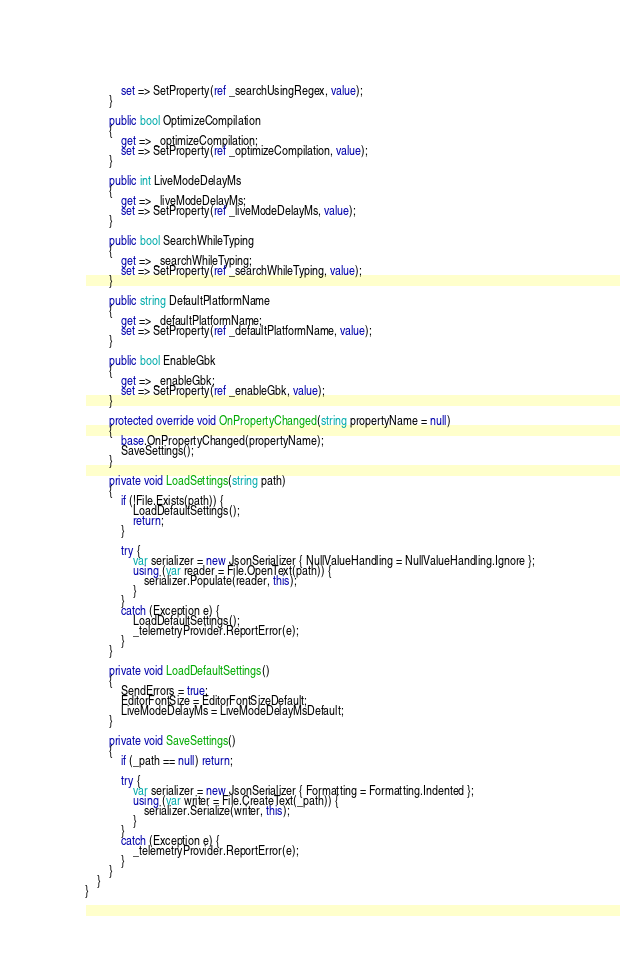Convert code to text. <code><loc_0><loc_0><loc_500><loc_500><_C#_>            set => SetProperty(ref _searchUsingRegex, value);
        }

        public bool OptimizeCompilation
        {
            get => _optimizeCompilation;
            set => SetProperty(ref _optimizeCompilation, value);
        }

        public int LiveModeDelayMs
        {
            get => _liveModeDelayMs;
            set => SetProperty(ref _liveModeDelayMs, value);
        }

        public bool SearchWhileTyping
        {
            get => _searchWhileTyping;
            set => SetProperty(ref _searchWhileTyping, value);
        }

        public string DefaultPlatformName
        {
            get => _defaultPlatformName;
            set => SetProperty(ref _defaultPlatformName, value);
        }

        public bool EnableGbk
        {
            get => _enableGbk;
            set => SetProperty(ref _enableGbk, value);
        }

        protected override void OnPropertyChanged(string propertyName = null)
        {
            base.OnPropertyChanged(propertyName);
            SaveSettings();
        }

        private void LoadSettings(string path)
        {
            if (!File.Exists(path)) {
                LoadDefaultSettings();
                return;
            }

            try {
                var serializer = new JsonSerializer { NullValueHandling = NullValueHandling.Ignore };
                using (var reader = File.OpenText(path)) {
                    serializer.Populate(reader, this);
                }
            }
            catch (Exception e) {
                LoadDefaultSettings();
                _telemetryProvider.ReportError(e);
            }
        }

        private void LoadDefaultSettings()
        {
            SendErrors = true;
            EditorFontSize = EditorFontSizeDefault;
            LiveModeDelayMs = LiveModeDelayMsDefault;
        }

        private void SaveSettings()
        {
            if (_path == null) return;

            try {
                var serializer = new JsonSerializer { Formatting = Formatting.Indented };
                using (var writer = File.CreateText(_path)) {
                    serializer.Serialize(writer, this);
                }
            }
            catch (Exception e) {
                _telemetryProvider.ReportError(e);
            }
        }
    }
}</code> 